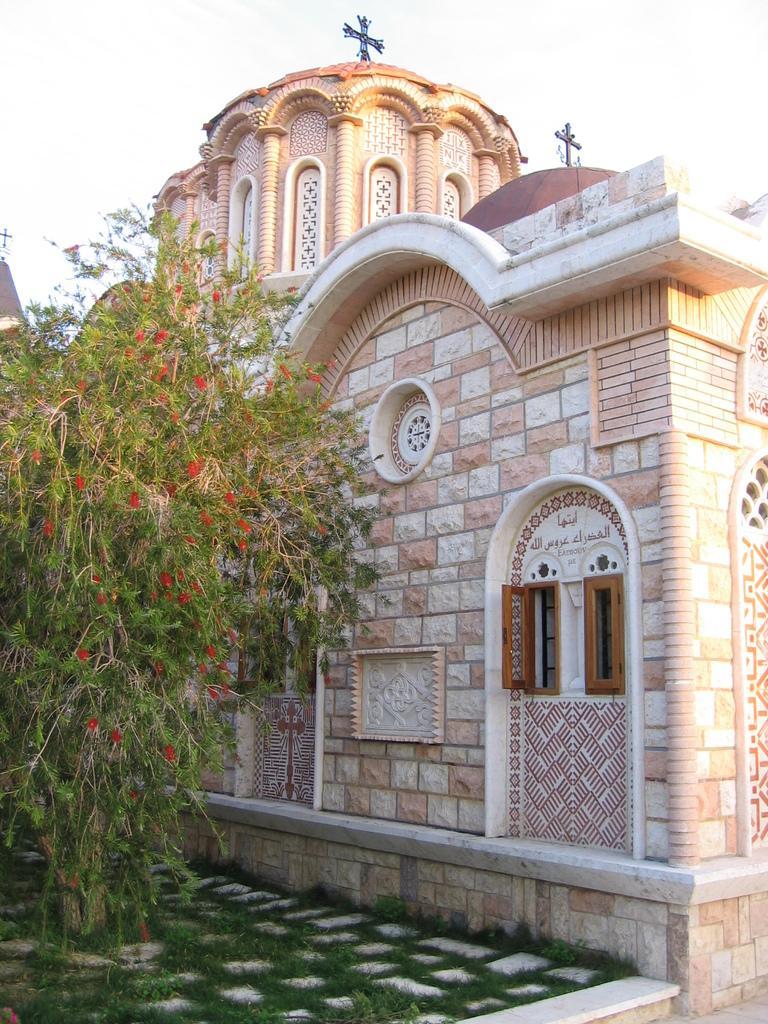Please provide a concise description of this image. In this image I see a building and I see the path on which there is green grass and I see the plants and I see red color flowers on it. In the background I see the sky. 